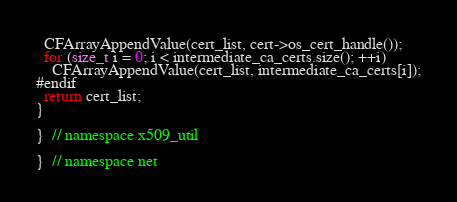<code> <loc_0><loc_0><loc_500><loc_500><_C++_>  CFArrayAppendValue(cert_list, cert->os_cert_handle());
  for (size_t i = 0; i < intermediate_ca_certs.size(); ++i)
    CFArrayAppendValue(cert_list, intermediate_ca_certs[i]);
#endif
  return cert_list;
}

}  // namespace x509_util

}  // namespace net
</code> 